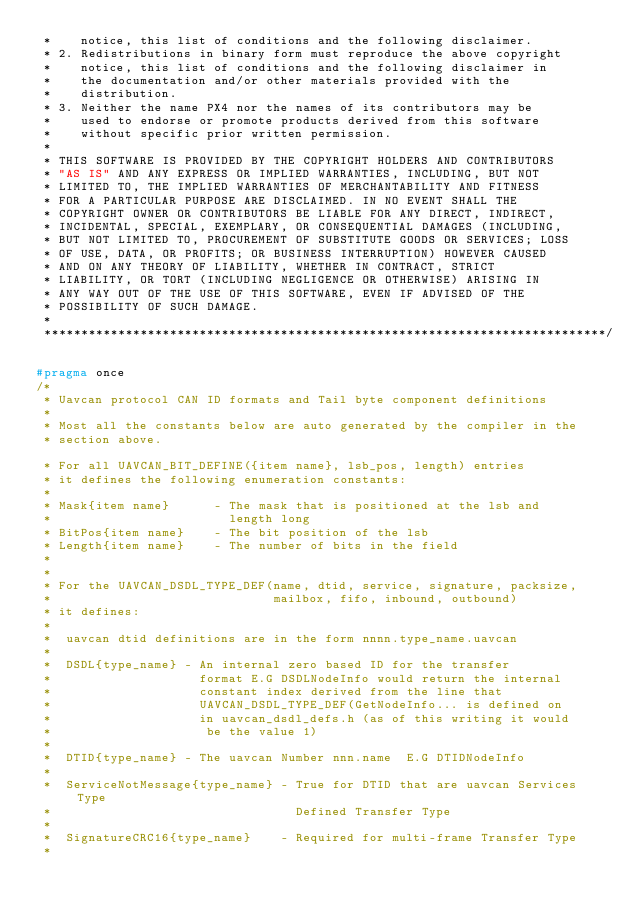Convert code to text. <code><loc_0><loc_0><loc_500><loc_500><_C_> *    notice, this list of conditions and the following disclaimer.
 * 2. Redistributions in binary form must reproduce the above copyright
 *    notice, this list of conditions and the following disclaimer in
 *    the documentation and/or other materials provided with the
 *    distribution.
 * 3. Neither the name PX4 nor the names of its contributors may be
 *    used to endorse or promote products derived from this software
 *    without specific prior written permission.
 *
 * THIS SOFTWARE IS PROVIDED BY THE COPYRIGHT HOLDERS AND CONTRIBUTORS
 * "AS IS" AND ANY EXPRESS OR IMPLIED WARRANTIES, INCLUDING, BUT NOT
 * LIMITED TO, THE IMPLIED WARRANTIES OF MERCHANTABILITY AND FITNESS
 * FOR A PARTICULAR PURPOSE ARE DISCLAIMED. IN NO EVENT SHALL THE
 * COPYRIGHT OWNER OR CONTRIBUTORS BE LIABLE FOR ANY DIRECT, INDIRECT,
 * INCIDENTAL, SPECIAL, EXEMPLARY, OR CONSEQUENTIAL DAMAGES (INCLUDING,
 * BUT NOT LIMITED TO, PROCUREMENT OF SUBSTITUTE GOODS OR SERVICES; LOSS
 * OF USE, DATA, OR PROFITS; OR BUSINESS INTERRUPTION) HOWEVER CAUSED
 * AND ON ANY THEORY OF LIABILITY, WHETHER IN CONTRACT, STRICT
 * LIABILITY, OR TORT (INCLUDING NEGLIGENCE OR OTHERWISE) ARISING IN
 * ANY WAY OUT OF THE USE OF THIS SOFTWARE, EVEN IF ADVISED OF THE
 * POSSIBILITY OF SUCH DAMAGE.
 *
 ****************************************************************************/

#pragma once
/*
 * Uavcan protocol CAN ID formats and Tail byte component definitions
 *
 * Most all the constants below are auto generated by the compiler in the
 * section above.

 * For all UAVCAN_BIT_DEFINE({item name}, lsb_pos, length) entries
 * it defines the following enumeration constants:
 *
 * Mask{item name}      - The mask that is positioned at the lsb and
 *                        length long
 * BitPos{item name}    - The bit position of the lsb
 * Length{item name}    - The number of bits in the field
 *
 *
 * For the UAVCAN_DSDL_TYPE_DEF(name, dtid, service, signature, packsize,
 *                              mailbox, fifo, inbound, outbound)
 * it defines:
 *
 *  uavcan dtid definitions are in the form nnnn.type_name.uavcan
 *
 *  DSDL{type_name} - An internal zero based ID for the transfer
 *                    format E.G DSDLNodeInfo would return the internal
 *                    constant index derived from the line that
 *                    UAVCAN_DSDL_TYPE_DEF(GetNodeInfo... is defined on
 *                    in uavcan_dsdl_defs.h (as of this writing it would
 *                     be the value 1)
 *
 *  DTID{type_name} - The uavcan Number nnn.name  E.G DTIDNodeInfo
 *
 *  ServiceNotMessage{type_name} - True for DTID that are uavcan Services Type
 *                                 Defined Transfer Type
 *
 *  SignatureCRC16{type_name}    - Required for multi-frame Transfer Type
 *</code> 